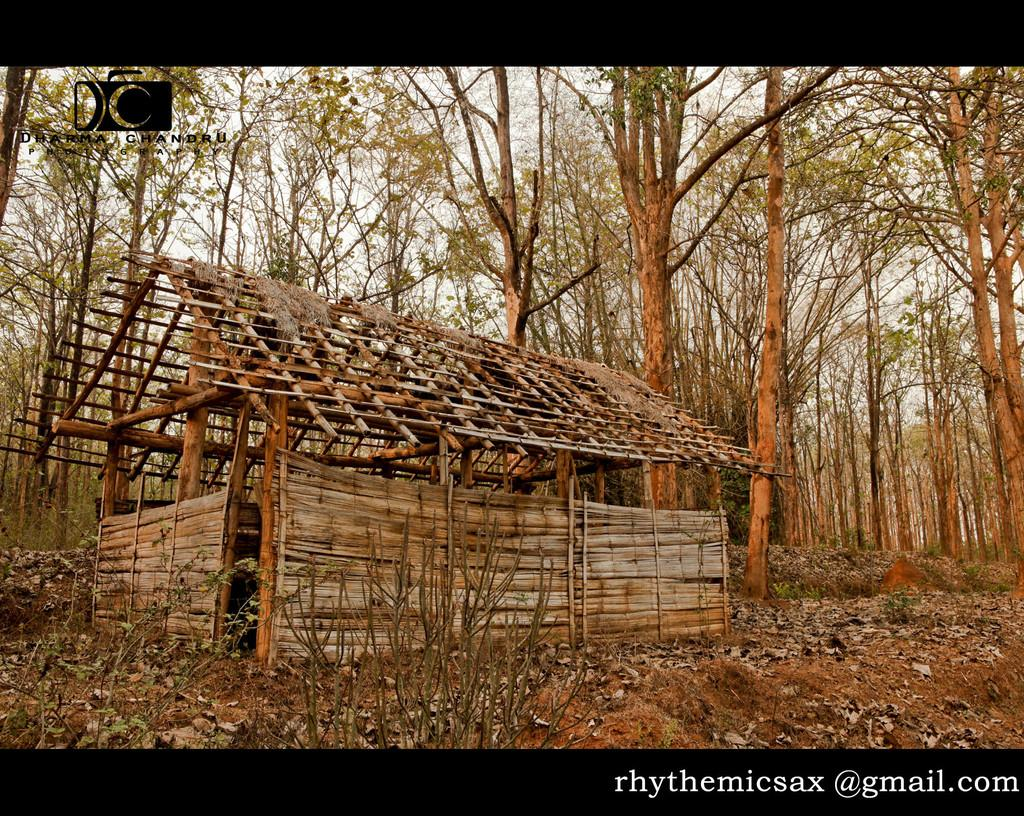What type of house is depicted in the image? There is a house made up of wooden logs in the image. What can be seen in the background of the image? There are many trees and the sky visible in the background of the image. What type of agreement is being signed in the image? There is no agreement or signing activity depicted in the image; it features a wooden log house with trees and sky in the background. How many cabbages are present in the image? There are no cabbages present in the image. 